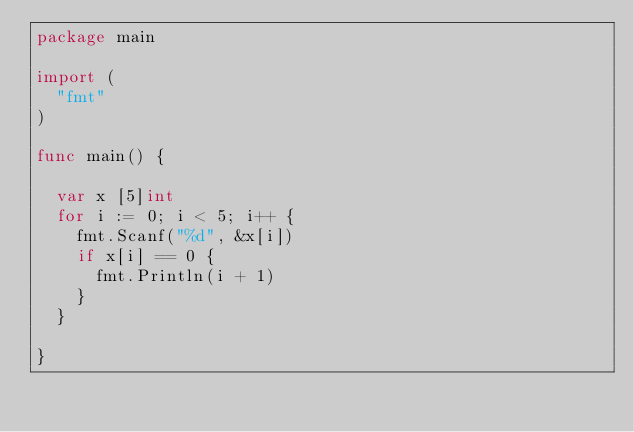Convert code to text. <code><loc_0><loc_0><loc_500><loc_500><_Go_>package main

import (
	"fmt"
)

func main() {

	var x [5]int
	for i := 0; i < 5; i++ {
		fmt.Scanf("%d", &x[i])
		if x[i] == 0 {
			fmt.Println(i + 1)
		}
	}

}</code> 